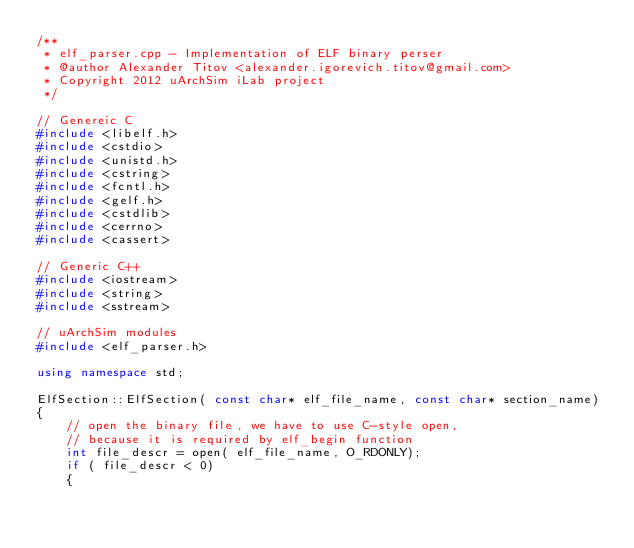Convert code to text. <code><loc_0><loc_0><loc_500><loc_500><_C++_>/**
 * elf_parser.cpp - Implementation of ELF binary perser
 * @author Alexander Titov <alexander.igorevich.titov@gmail.com>
 * Copyright 2012 uArchSim iLab project
 */

// Genereic C
#include <libelf.h>
#include <cstdio>
#include <unistd.h>
#include <cstring>
#include <fcntl.h>
#include <gelf.h>
#include <cstdlib>
#include <cerrno>
#include <cassert>

// Generic C++
#include <iostream>
#include <string>
#include <sstream>

// uArchSim modules
#include <elf_parser.h>

using namespace std;

ElfSection::ElfSection( const char* elf_file_name, const char* section_name)
{
    // open the binary file, we have to use C-style open,
    // because it is required by elf_begin function
    int file_descr = open( elf_file_name, O_RDONLY); 
    if ( file_descr < 0)
    {</code> 